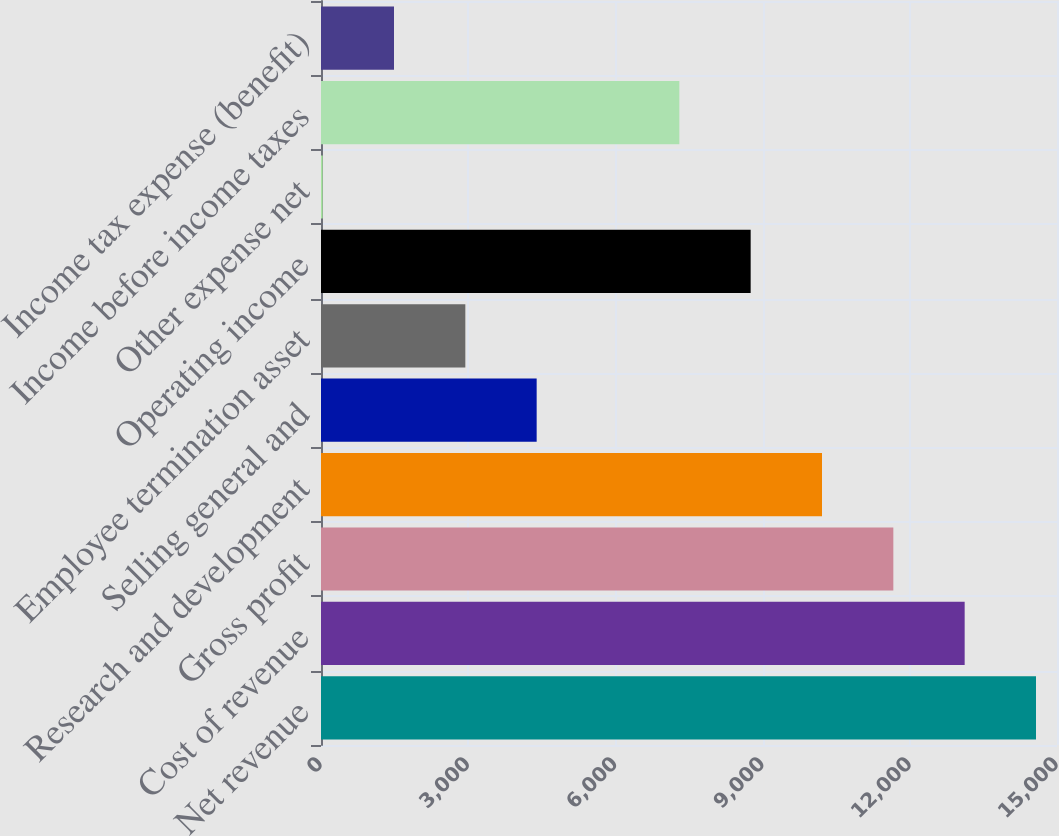<chart> <loc_0><loc_0><loc_500><loc_500><bar_chart><fcel>Net revenue<fcel>Cost of revenue<fcel>Gross profit<fcel>Research and development<fcel>Selling general and<fcel>Employee termination asset<fcel>Operating income<fcel>Other expense net<fcel>Income before income taxes<fcel>Income tax expense (benefit)<nl><fcel>14572<fcel>13118.2<fcel>11664.4<fcel>10210.6<fcel>4395.4<fcel>2941.6<fcel>8756.8<fcel>34<fcel>7303<fcel>1487.8<nl></chart> 